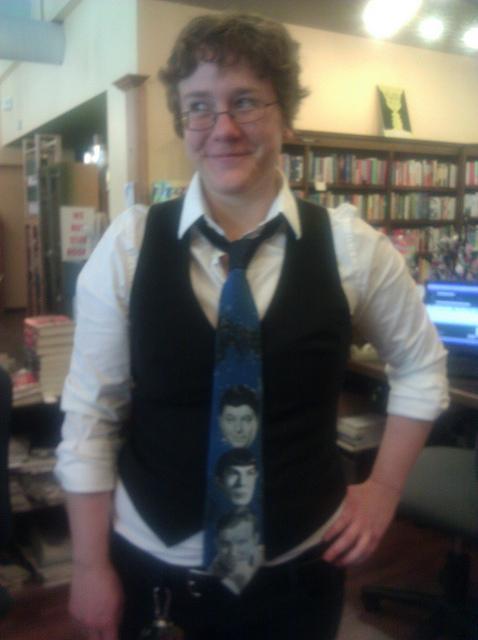What type of shop is the person wearing the tie in?
Indicate the correct choice and explain in the format: 'Answer: answer
Rationale: rationale.'
Options: Deli, restaurant, grocery store, book store. Answer: book store.
Rationale: The shelves behind the guy are stacked high with various books. 